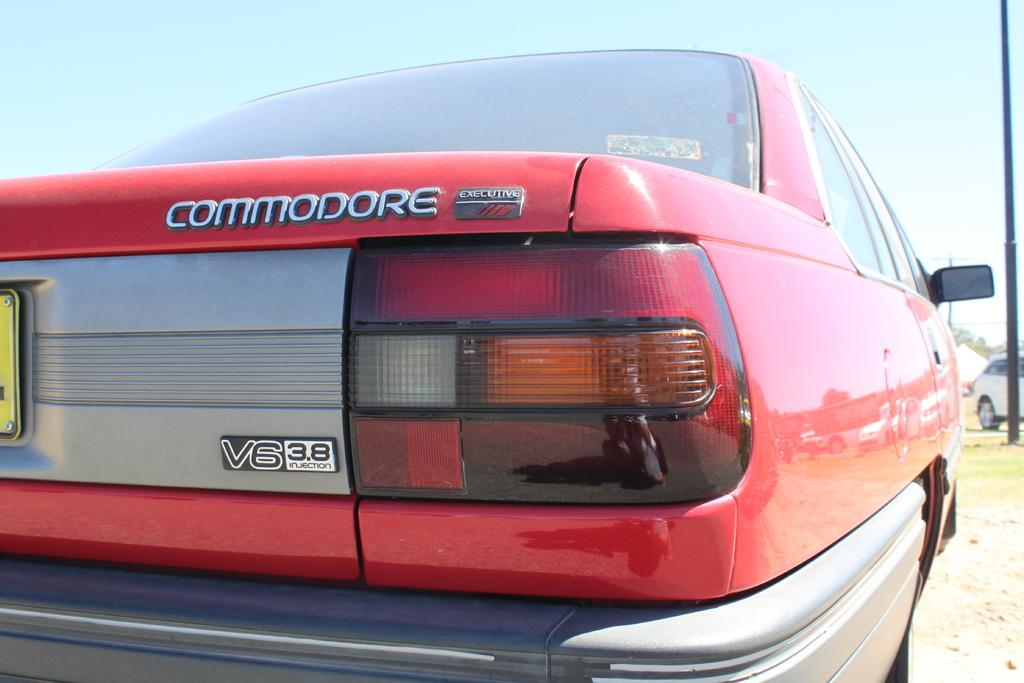What types of vehicles can be seen in the image? There are vehicles in the image, but the specific types are not mentioned. Which car stands out in the image? A red color car is highlighted in the image. What is the surface on which the vehicles are located? There is ground visible in the image. What is the tall, vertical object in the image? There is a pole in the image. What part of the natural environment is visible in the image? The sky is visible in the image. Can you see a tent set up near the vehicles in the image? There is no mention of a tent in the image, so it cannot be confirmed. Is there any ice visible in the image? There is no mention of ice in the image, so it cannot be confirmed. 